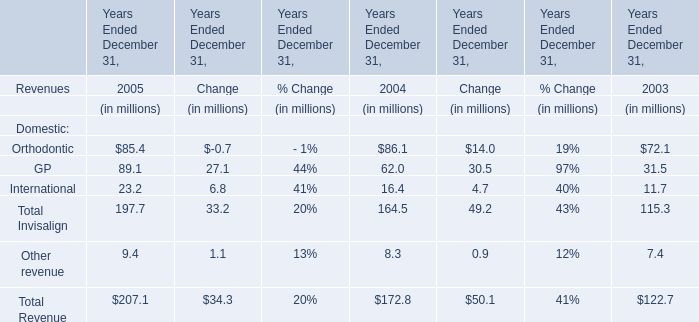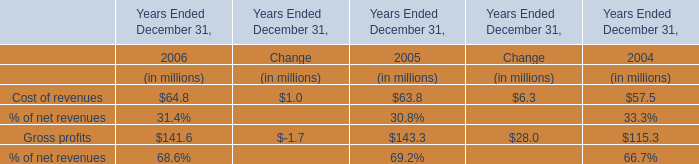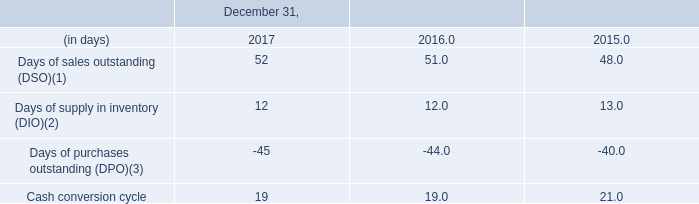What's the total amount of Domestic in 2005? (in million) 
Computations: (((((85.4 + 89.1) + 23.2) + 197.7) + 9.4) + 207.1)
Answer: 611.9. 